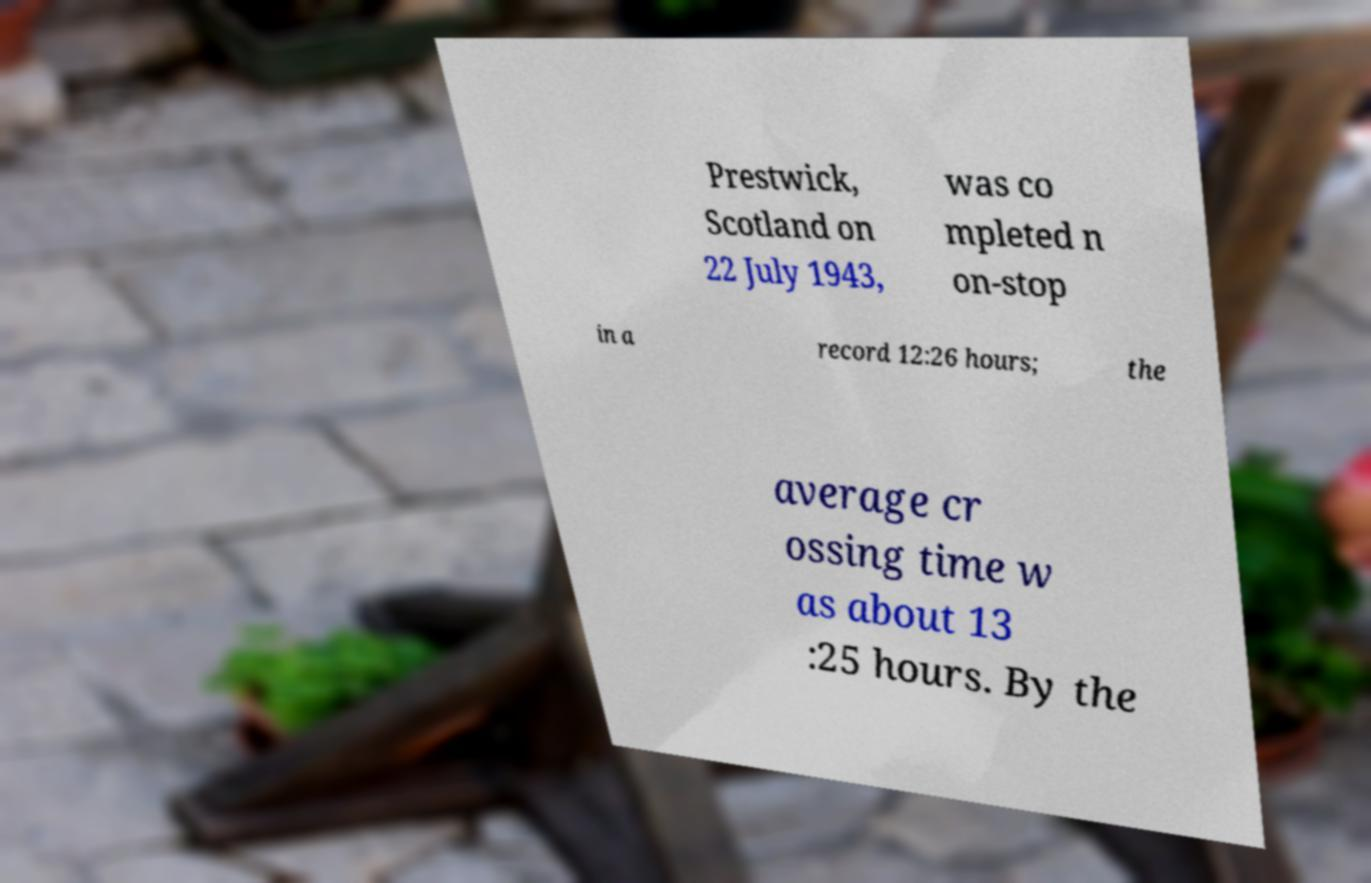Can you read and provide the text displayed in the image?This photo seems to have some interesting text. Can you extract and type it out for me? Prestwick, Scotland on 22 July 1943, was co mpleted n on-stop in a record 12:26 hours; the average cr ossing time w as about 13 :25 hours. By the 